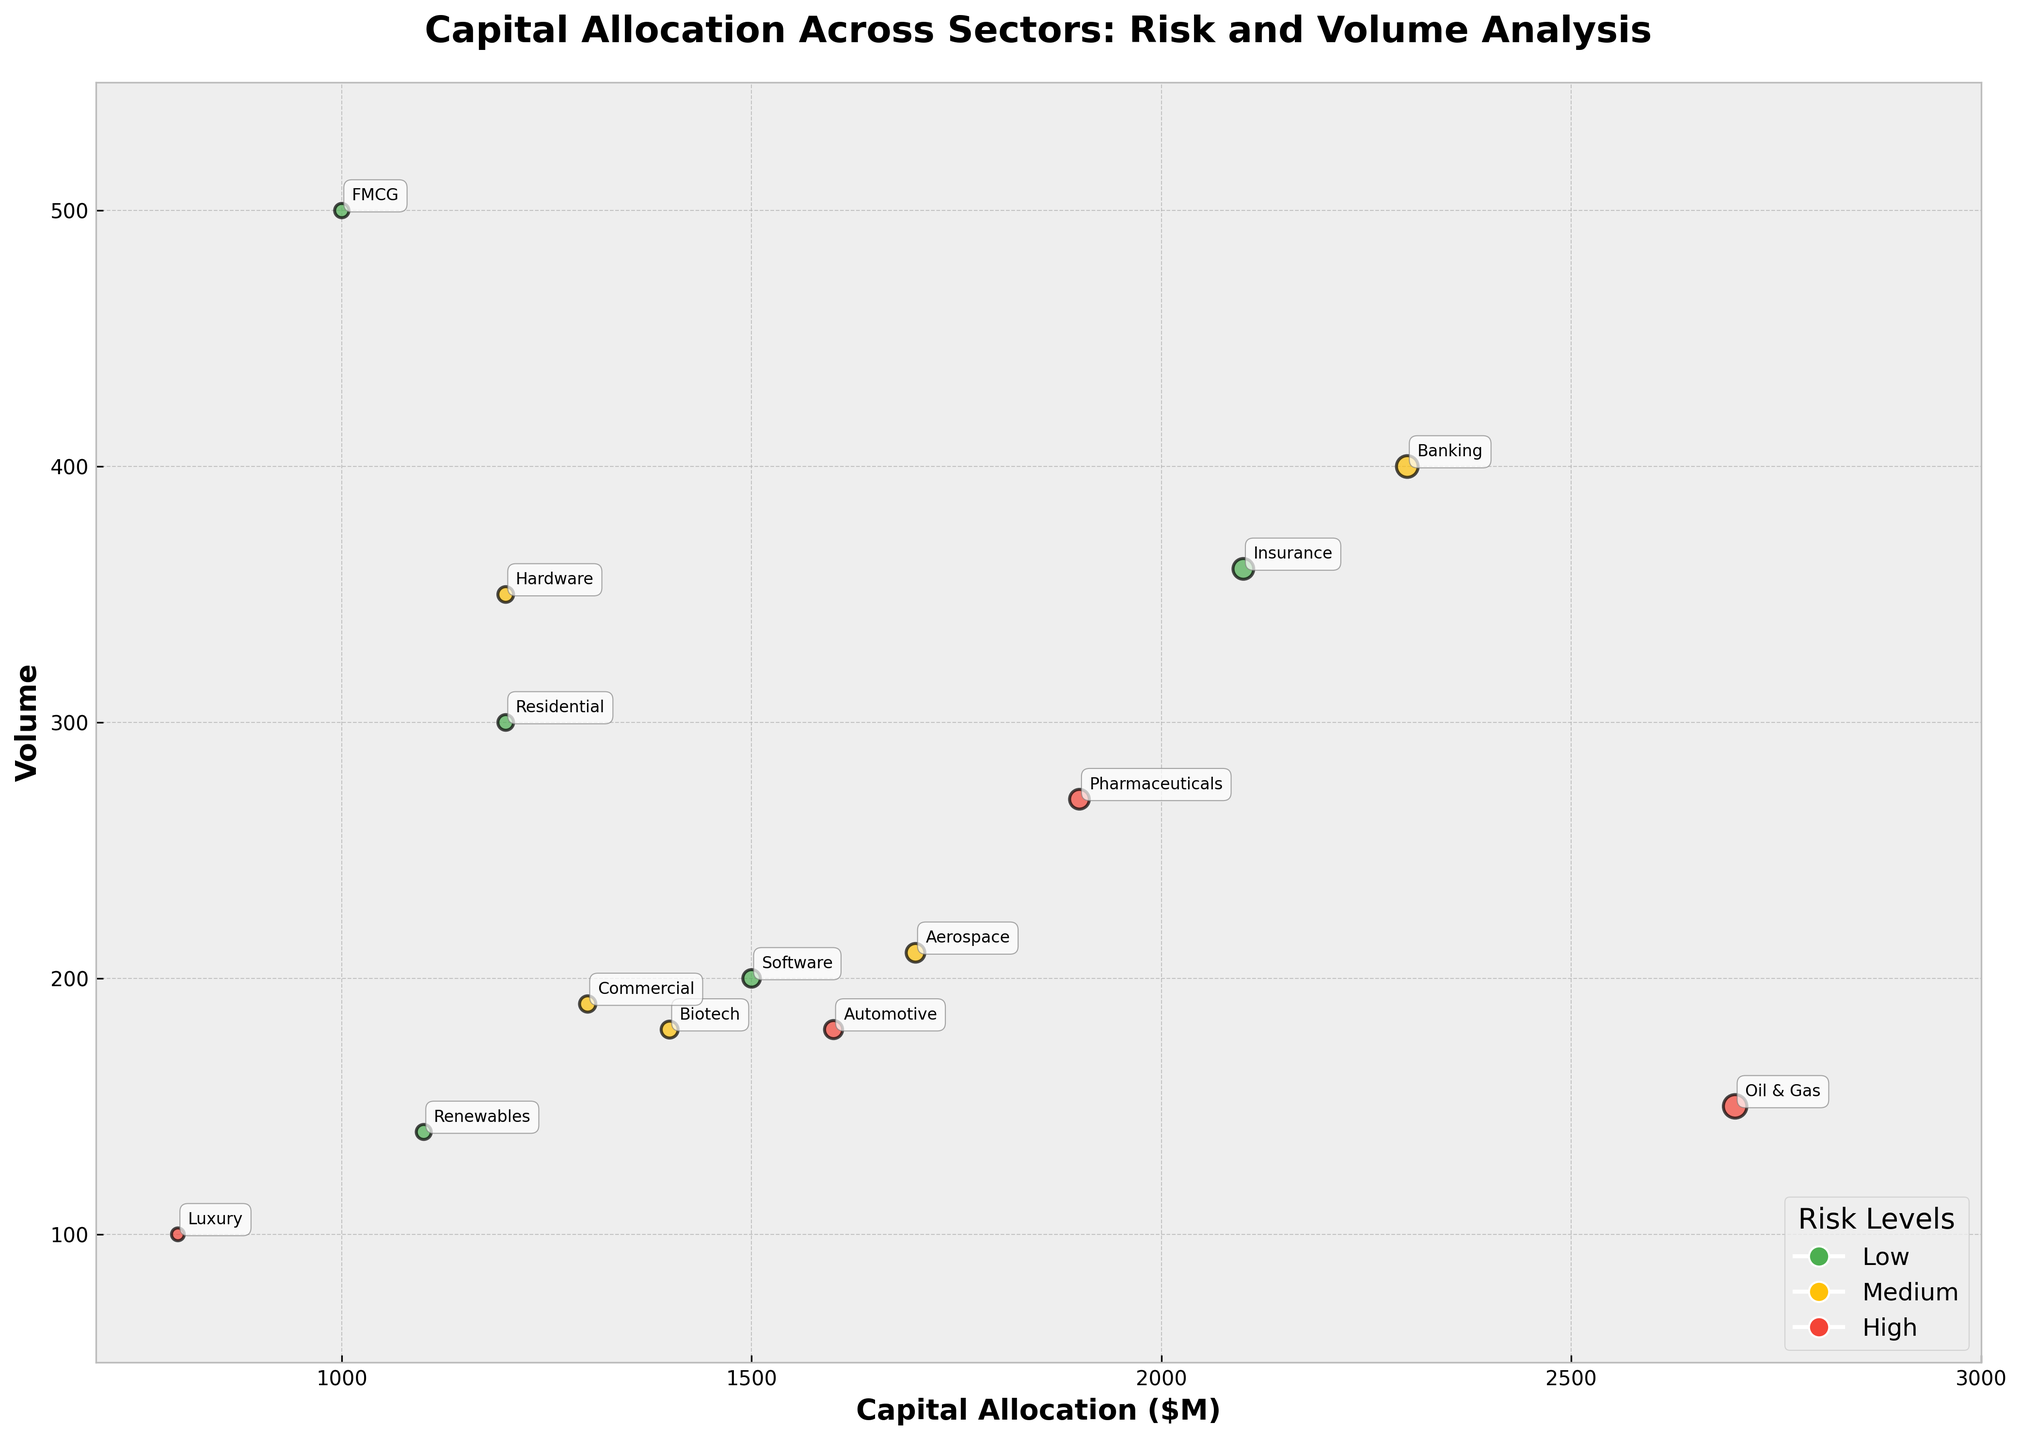Which sector has the bubble with the largest size? To find the bubble with the largest size, observe the one with the largest area. The size is based on capital allocation, so look for the bubble representing the largest capital allocation. The "Energy" sector, specifically the "Oil & Gas" subsector, has the largest bubble with a capital allocation of $2700M.
Answer: Energy What is the y-axis title of the plot? The y-axis title can be found on the vertical axis of the plot. It reads "Volume."
Answer: Volume Which subsector in the Technology sector has a higher risk level, Software or Hardware? To find this, compare the Risk Levels of the subsectors under the Technology sector. Software has a Low risk level, while Hardware has a Medium risk level.
Answer: Hardware How many subsectors have a High risk level in the Finance sector? To answer this, identify the subsectors within the Finance sector and check their risk levels. The Finance sector includes Banking and Insurance, both labeled as Medium and Low risk levels respectively. Thus, there are no High risk level subsectors in Finance.
Answer: 0 Which sector has a greater capital allocation, Healthcare or Real Estate? Compare the total capital allocations of the Healthcare and Real Estate sectors. Healthcare has Pharmaceuticals ($1900M) and Biotech ($1400M), summing up to $3300M. Real Estate has Commercial ($1300M) and Residential ($1200M), summing up to $2500M. Healthcare has a greater capital allocation.
Answer: Healthcare Between which range are most of the bubbles in terms of capital allocation on the x-axis? To determine this, observe the distribution of bubbles on the x-axis representing capital allocation. Most bubbles are between $1200M and $2300M.
Answer: $1200M and $2300M Which subsector in the Consumer Goods sector has a higher volume, FMCG or Luxury? Compare the volumes of the FMCG and Luxury subsectors in the Consumer Goods sector. FMCG has a volume of 500, while Luxury has a volume of 100. FMCG has a higher volume.
Answer: FMCG 